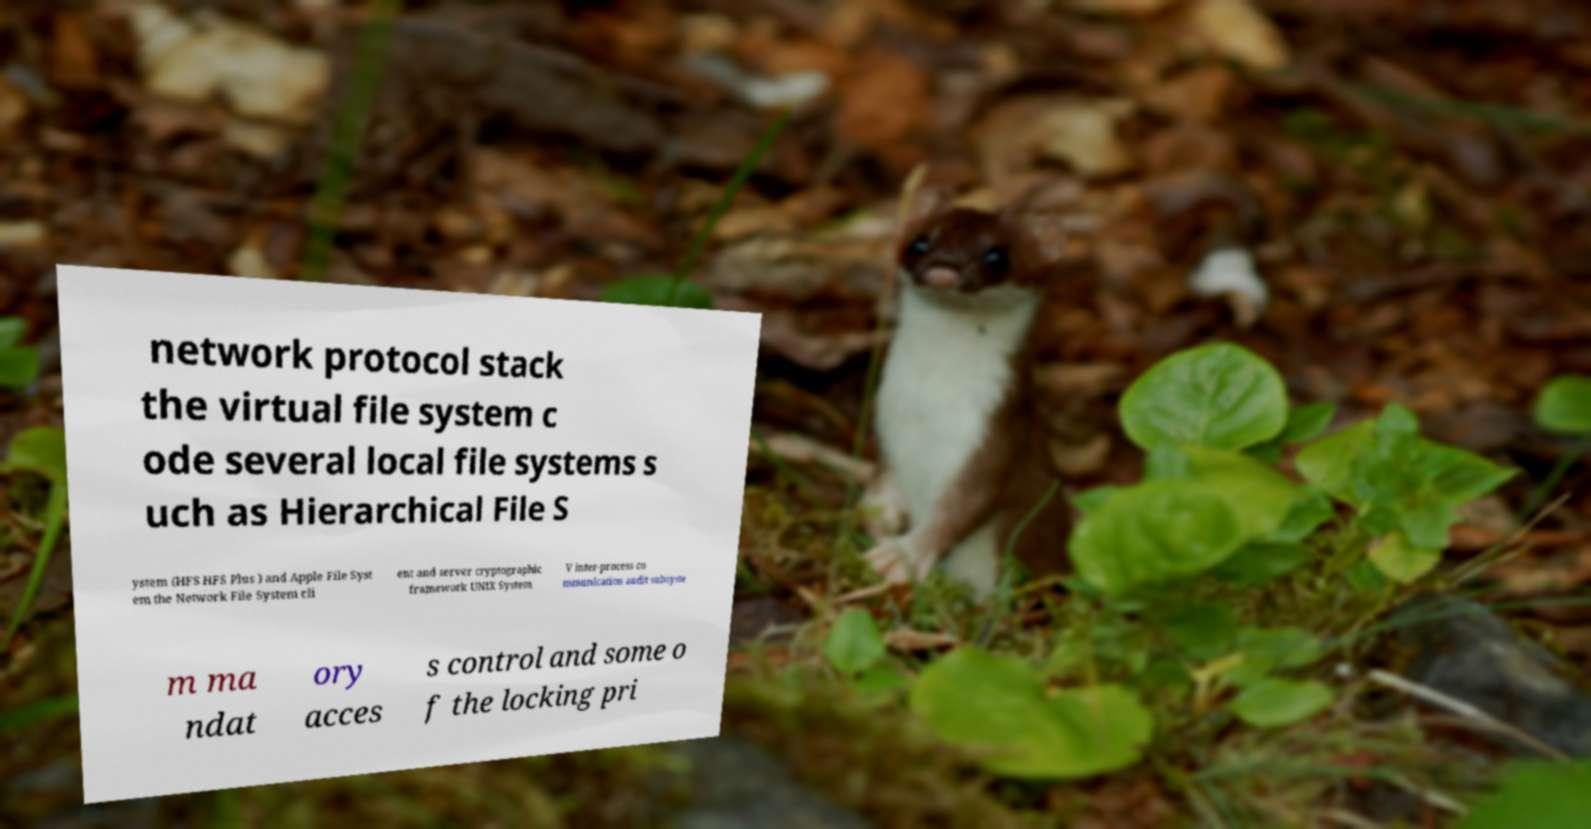Please identify and transcribe the text found in this image. network protocol stack the virtual file system c ode several local file systems s uch as Hierarchical File S ystem (HFS HFS Plus ) and Apple File Syst em the Network File System cli ent and server cryptographic framework UNIX System V inter-process co mmunication audit subsyste m ma ndat ory acces s control and some o f the locking pri 